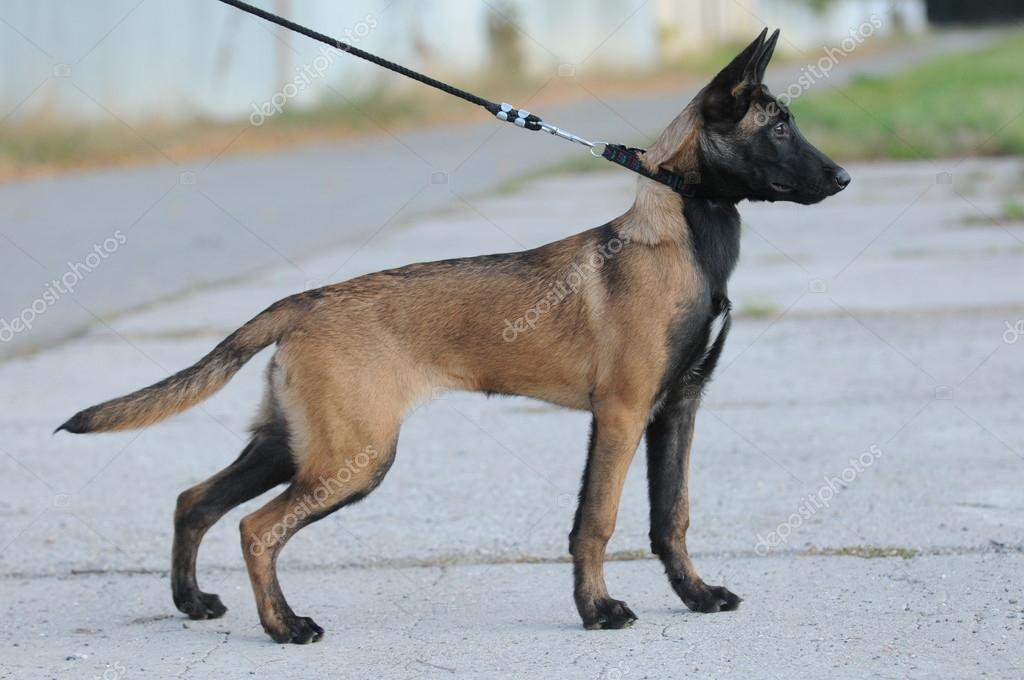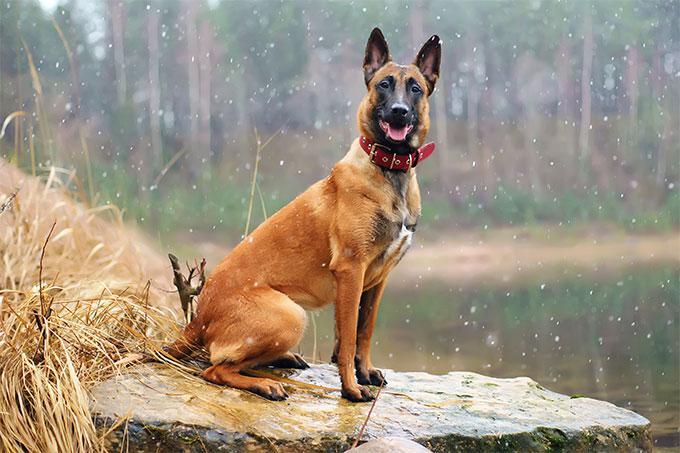The first image is the image on the left, the second image is the image on the right. Analyze the images presented: Is the assertion "In one of the images, a dog is wearing a leash attached to a collar" valid? Answer yes or no. Yes. 